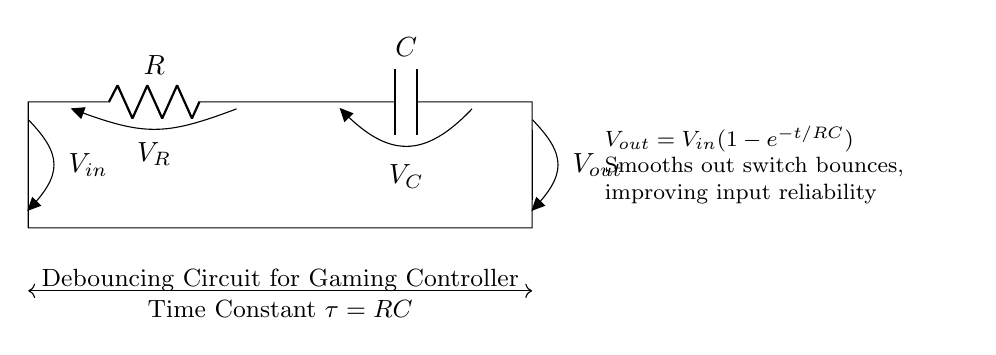What are the components in this circuit? The circuit consists of a resistor and a capacitor, as indicated by the labels R and C. These are the basic components used to create the debouncing effect.
Answer: Resistor and Capacitor What does the voltage across the capacitor represent? The voltage across the capacitor, labeled as V_C, indicates the charge stored in the capacitor as it charges up when the switch is activated.
Answer: Voltage across the capacitor What is the function of the resistor in this circuit? The resistor limits the charge current to the capacitor, which helps control the time constant for the circuit, affecting how quickly it responds to switch changes.
Answer: Current limiting What is the time constant of this circuit? The time constant is defined as the product of the resistance and capacitance (τ = RC), which determines the speed of the charging and discharging of the capacitor.
Answer: RC How does this circuit improve input reliability? This circuit smooths out voltage fluctuations caused by switch bouncing, which can lead to erroneous signals, thus improving the reliability of input detection in the controller.
Answer: Smoothing out switch bounces What happens to V_out when the switch is pressed? When the switch is pressed, V_out increases towards V_in, as the capacitor begins to charge according to the exponential charging equation given in the circuit.
Answer: Increases towards V_in What effect does increasing R or C have on the time constant? Increasing either the resistance or capacitance increases the time constant τ, resulting in a slower charge and discharge rate for the capacitor.
Answer: Increases time constant 